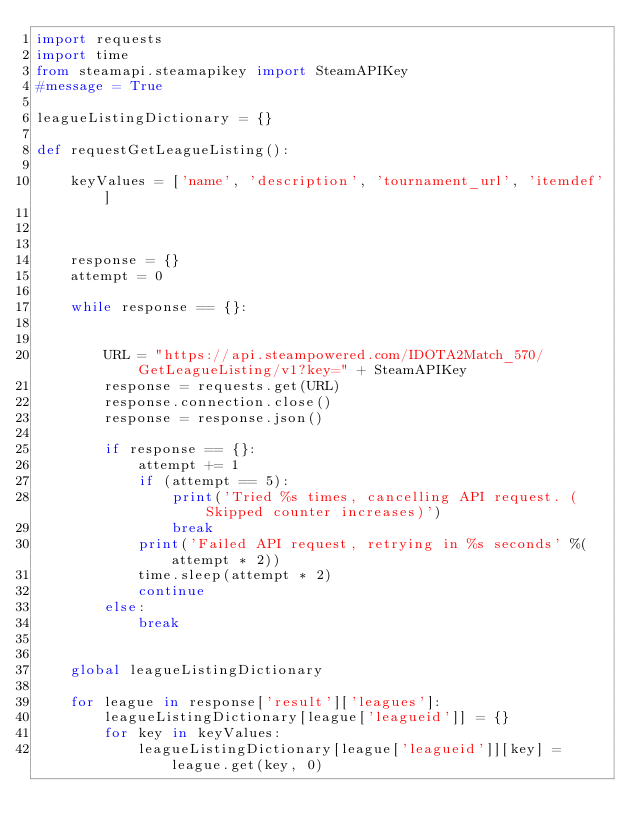<code> <loc_0><loc_0><loc_500><loc_500><_Python_>import requests
import time
from steamapi.steamapikey import SteamAPIKey
#message = True

leagueListingDictionary = {}

def requestGetLeagueListing():

    keyValues = ['name', 'description', 'tournament_url', 'itemdef']



    response = {}
    attempt = 0

    while response == {}:


        URL = "https://api.steampowered.com/IDOTA2Match_570/GetLeagueListing/v1?key=" + SteamAPIKey
        response = requests.get(URL)
        response.connection.close()
        response = response.json()

        if response == {}:
            attempt += 1
            if (attempt == 5):
                print('Tried %s times, cancelling API request. (Skipped counter increases)')
                break
            print('Failed API request, retrying in %s seconds' %(attempt * 2))
            time.sleep(attempt * 2)
            continue
        else:
            break


    global leagueListingDictionary

    for league in response['result']['leagues']:
        leagueListingDictionary[league['leagueid']] = {}
        for key in keyValues:
            leagueListingDictionary[league['leagueid']][key] = league.get(key, 0)</code> 